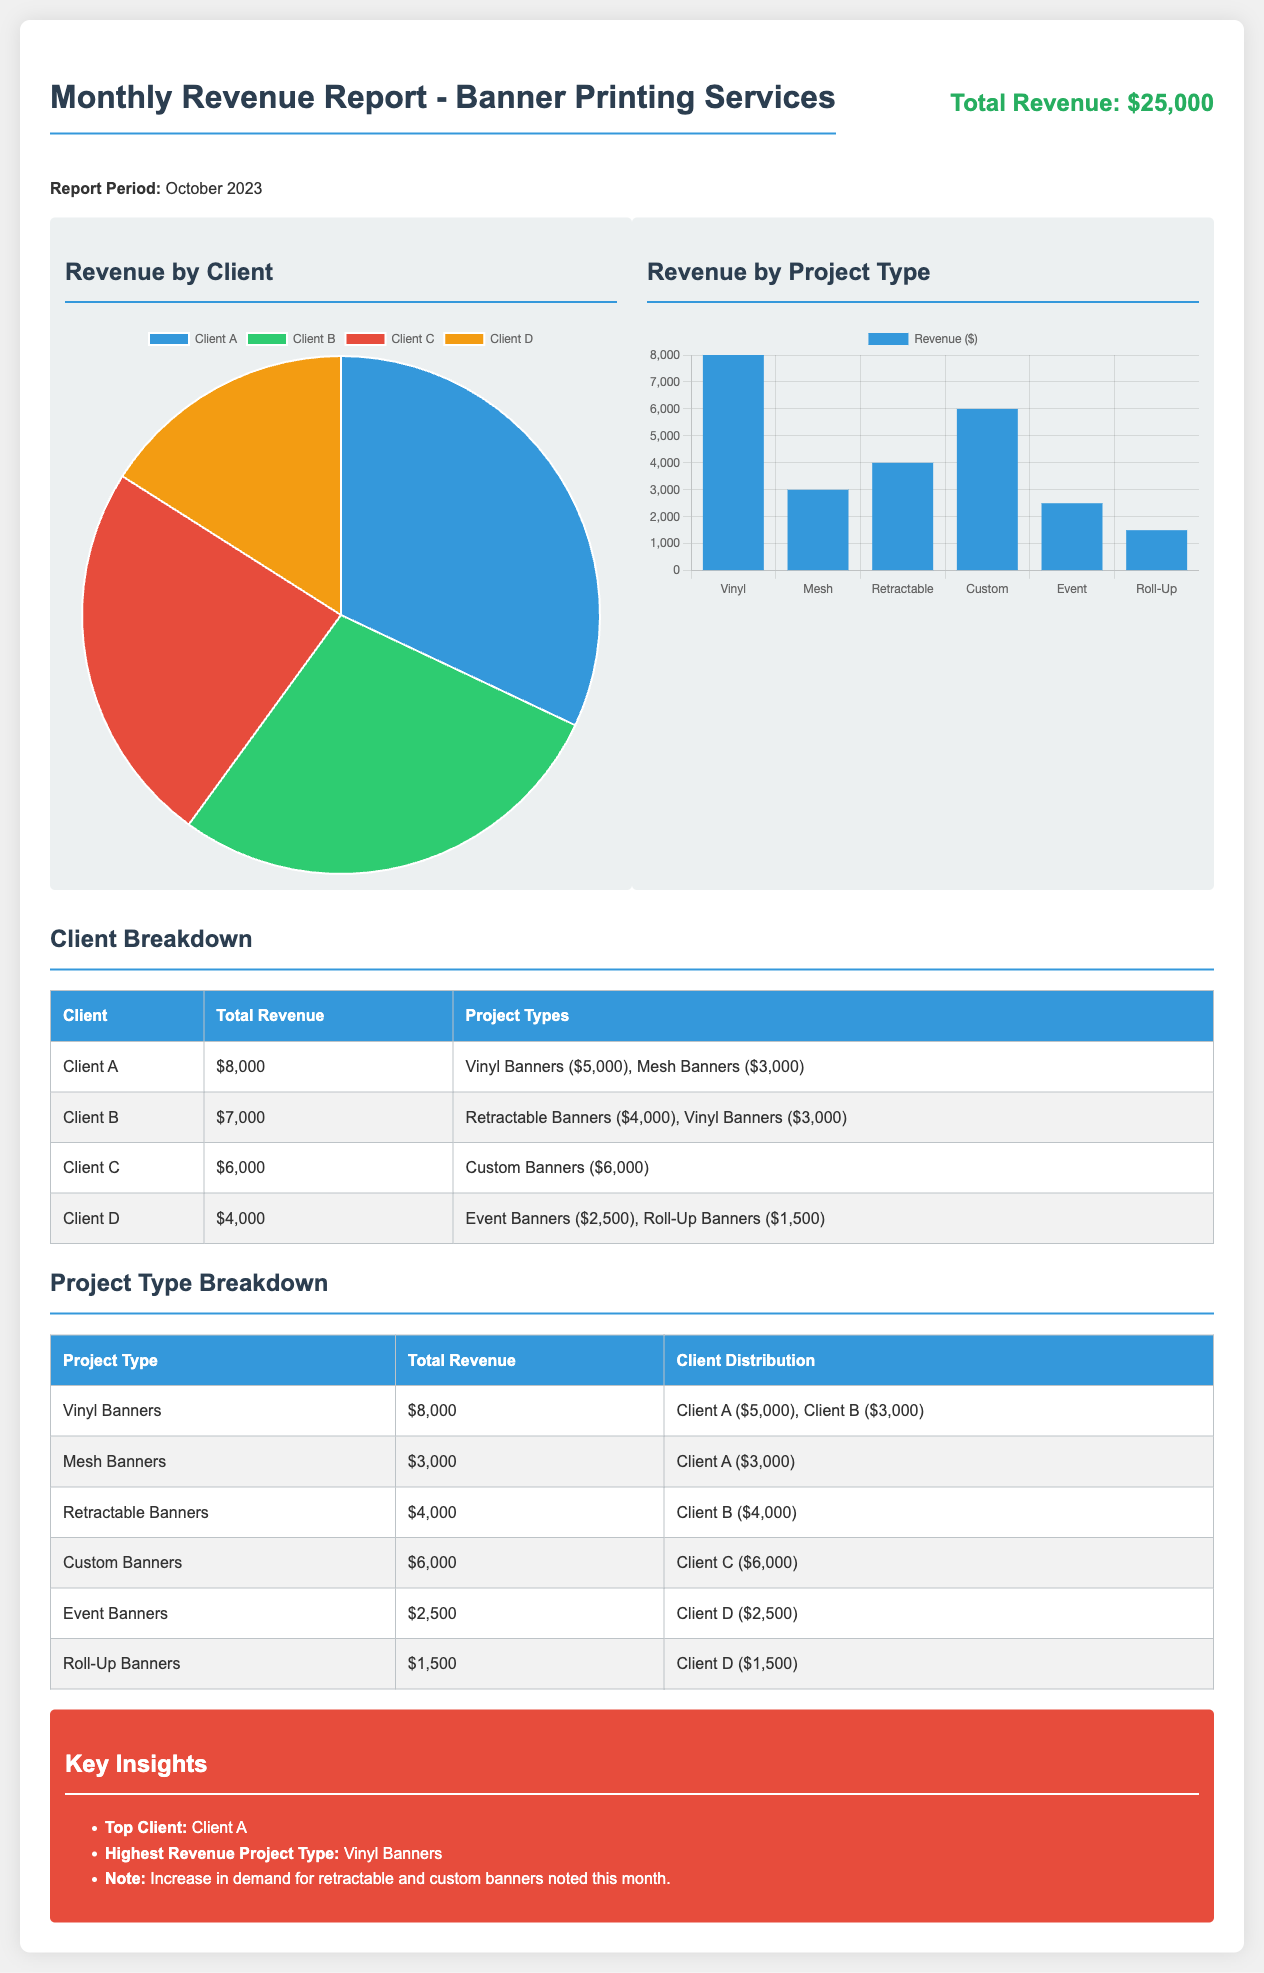What is the total revenue? The total revenue is provided in the report header, which states the amount of $25,000 for October 2023.
Answer: $25,000 Who is the top client? The key insights section of the report designates Client A as the top client based on revenue.
Answer: Client A What is the revenue from Custom Banners? The project type breakdown table lists the total revenue from Custom Banners as $6,000.
Answer: $6,000 What project type earned the highest revenue? According to the key insights, Vinyl Banners rank as the highest revenue project type.
Answer: Vinyl Banners How much revenue did Client D generate? The breakdown table shows that Client D generated a total revenue of $4,000.
Answer: $4,000 What is the revenue for Mesh Banners? The project type breakdown indicates that the revenue for Mesh Banners is $3,000.
Answer: $3,000 How many clients contributed to revenue from Retractable Banners? The project type breakdown reveals that only Client B contributed to the revenue from Retractable Banners of $4,000.
Answer: 1 client How much revenue did Vinyl Banners generate? The project type breakdown distinctly states that Vinyl Banners generated a total revenue of $8,000.
Answer: $8,000 What percentage of the total revenue was from Client B? By dividing Client B's revenue of $7,000 by the total revenue of $25,000 and multiplying by 100, we find that Client B constitutes 28% of the total revenue.
Answer: 28% 